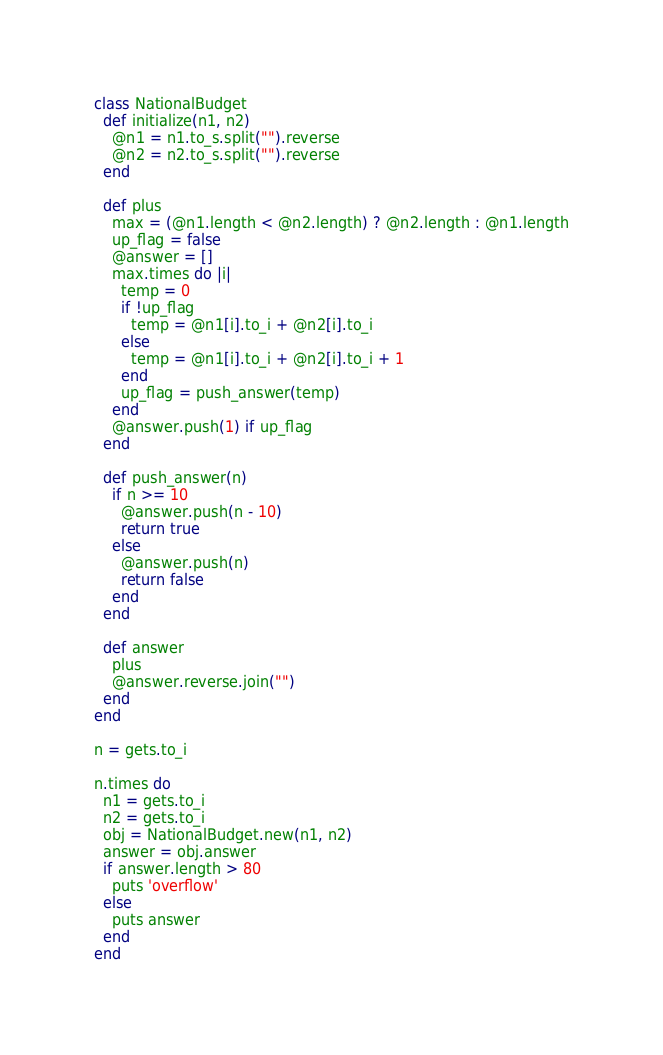<code> <loc_0><loc_0><loc_500><loc_500><_Ruby_>class NationalBudget
  def initialize(n1, n2)
    @n1 = n1.to_s.split("").reverse
    @n2 = n2.to_s.split("").reverse
  end

  def plus
    max = (@n1.length < @n2.length) ? @n2.length : @n1.length
    up_flag = false
    @answer = []
    max.times do |i|
      temp = 0
      if !up_flag
        temp = @n1[i].to_i + @n2[i].to_i
      else
        temp = @n1[i].to_i + @n2[i].to_i + 1
      end
      up_flag = push_answer(temp)
    end
    @answer.push(1) if up_flag
  end

  def push_answer(n)
    if n >= 10
      @answer.push(n - 10)
      return true
    else
      @answer.push(n)
      return false
    end
  end

  def answer
    plus
    @answer.reverse.join("")
  end
end

n = gets.to_i

n.times do
  n1 = gets.to_i
  n2 = gets.to_i
  obj = NationalBudget.new(n1, n2)
  answer = obj.answer
  if answer.length > 80
    puts 'overflow'
  else
    puts answer
  end
end</code> 